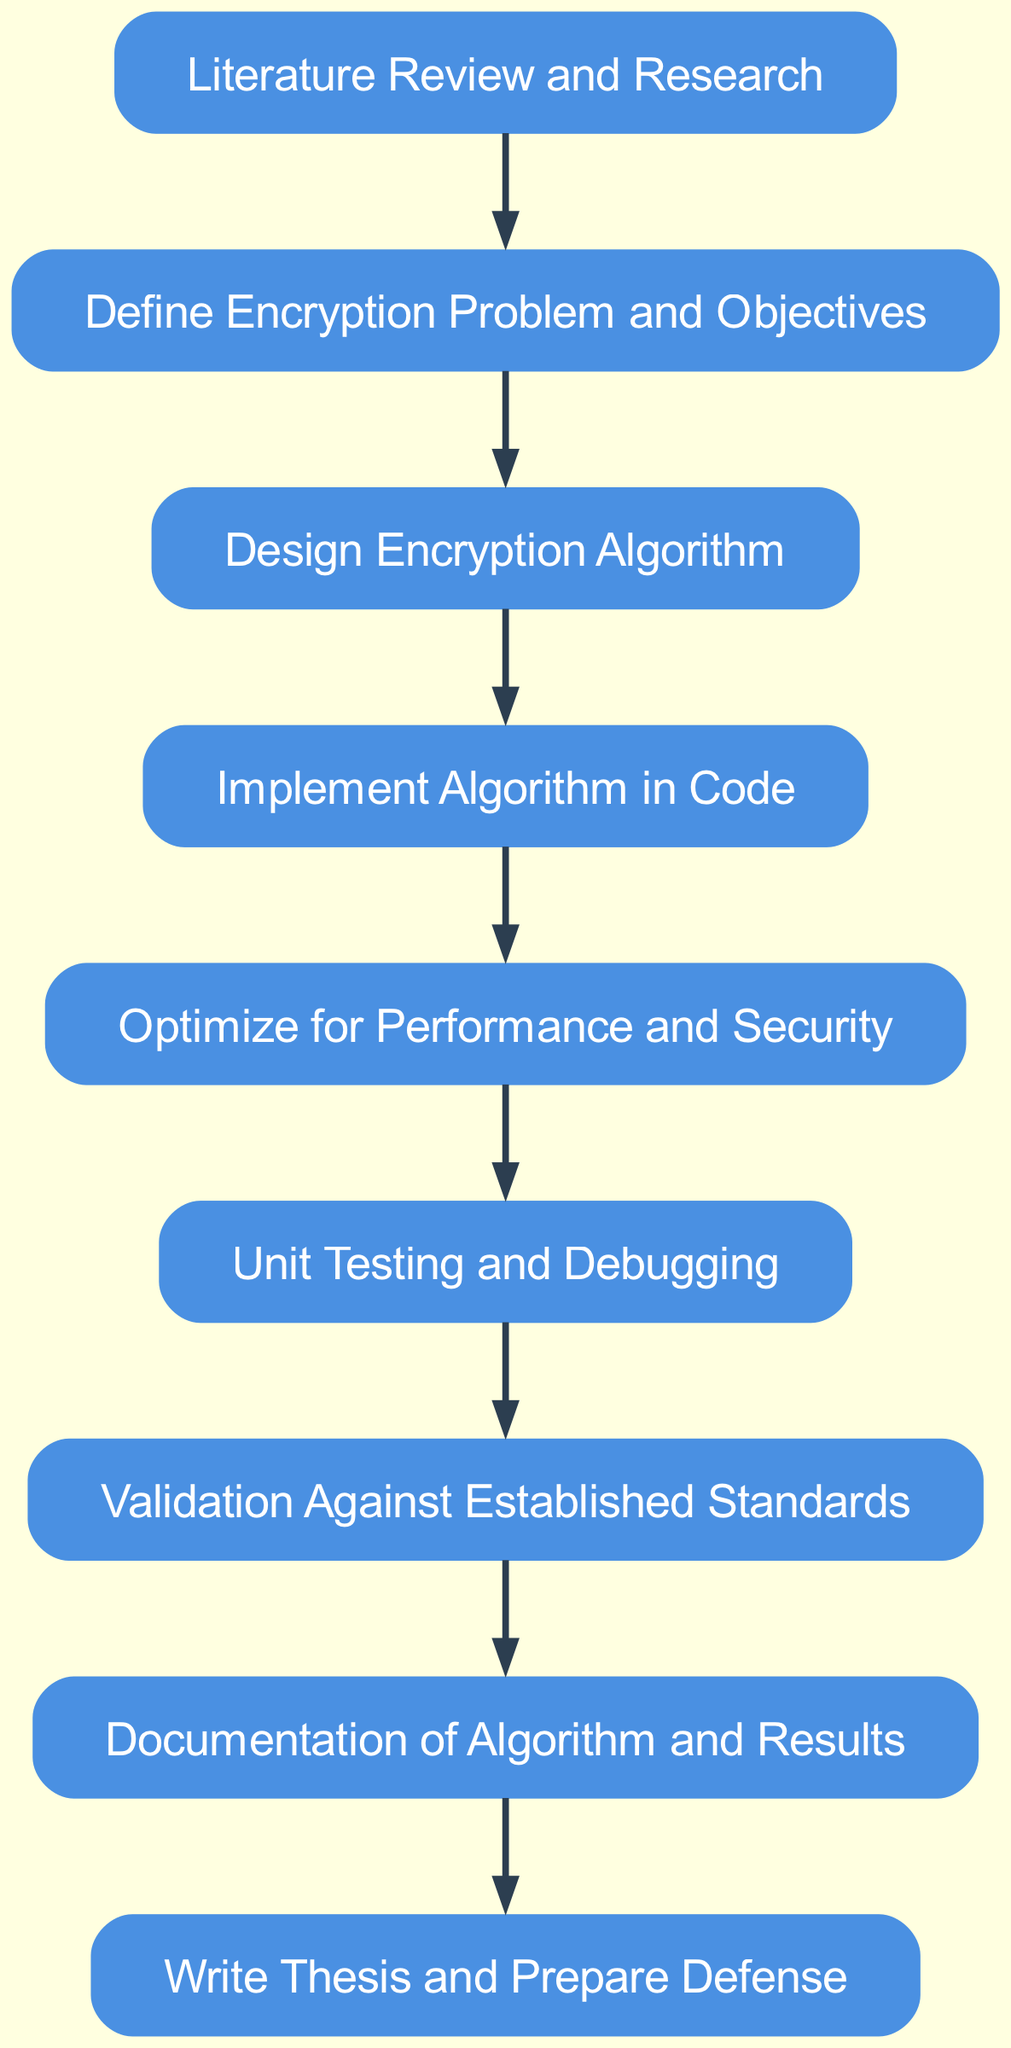What is the first stage in the workflow? The first stage listed in the diagram is "Literature Review and Research," which connects to the second stage.
Answer: Literature Review and Research How many nodes are present in the workflow? By counting the distinct stages in the diagram, there are nine nodes in total, representing different stages of the encryption algorithm development.
Answer: Nine What is the last stage before writing the thesis? The final stage before "Write Thesis and Prepare Defense" is "Documentation of Algorithm and Results," indicating what needs to be completed right before the thesis.
Answer: Documentation of Algorithm and Results Which node comes after "Unit Testing and Debugging"? According to the diagram, the node that follows "Unit Testing and Debugging" is "Validation Against Established Standards," showing the subsequent step in the process.
Answer: Validation Against Established Standards What is the relationship between "Optimization" and "Implementation"? The diagram shows a directed edge from "Implementation" to "Optimization," indicating that Optimization is a follow-up stage after the Implementation of the algorithm.
Answer: Implementation → Optimization What are the total edges in the workflow? By analyzing the connections (directed edges) between the nodes, there are eight edges that represent the flow from one stage to another in the workflow.
Answer: Eight Which node has no outgoing connections? The node "Write Thesis and Prepare Defense" does not point to any other node, highlighting that it is the final step in the workflow.
Answer: Write Thesis and Prepare Defense What does "Define Encryption Problem and Objectives" lead to? It directly leads to "Design Encryption Algorithm," indicating that after defining the problems, the next focus is on designing the algorithm.
Answer: Design Encryption Algorithm Which stage comes immediately after "Design Encryption Algorithm"? The stage that follows "Design Encryption Algorithm" is "Implement Algorithm in Code," showing the next action to be taken after the design phase.
Answer: Implement Algorithm in Code 